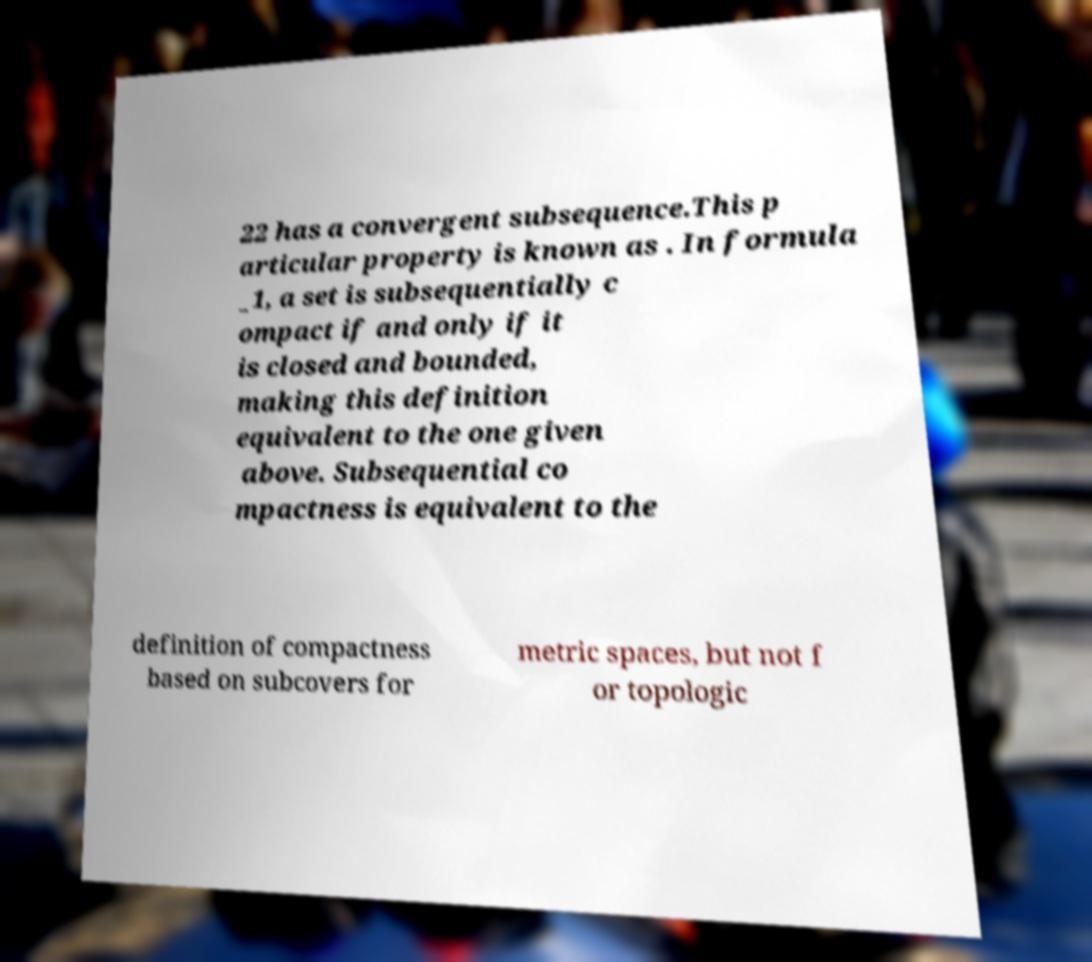Can you read and provide the text displayed in the image?This photo seems to have some interesting text. Can you extract and type it out for me? 22 has a convergent subsequence.This p articular property is known as . In formula _1, a set is subsequentially c ompact if and only if it is closed and bounded, making this definition equivalent to the one given above. Subsequential co mpactness is equivalent to the definition of compactness based on subcovers for metric spaces, but not f or topologic 